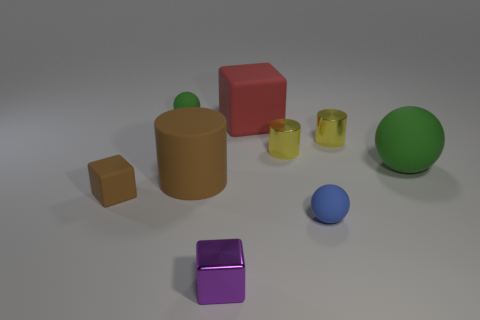Add 1 yellow metal cylinders. How many objects exist? 10 Subtract 0 cyan cylinders. How many objects are left? 9 Subtract all tiny blue rubber cylinders. Subtract all red rubber objects. How many objects are left? 8 Add 3 big matte blocks. How many big matte blocks are left? 4 Add 7 tiny brown objects. How many tiny brown objects exist? 8 